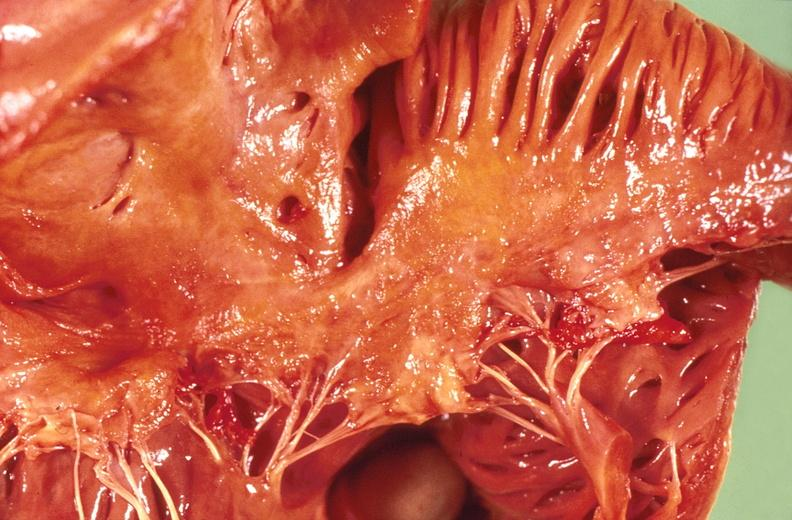where is this?
Answer the question using a single word or phrase. Heart 